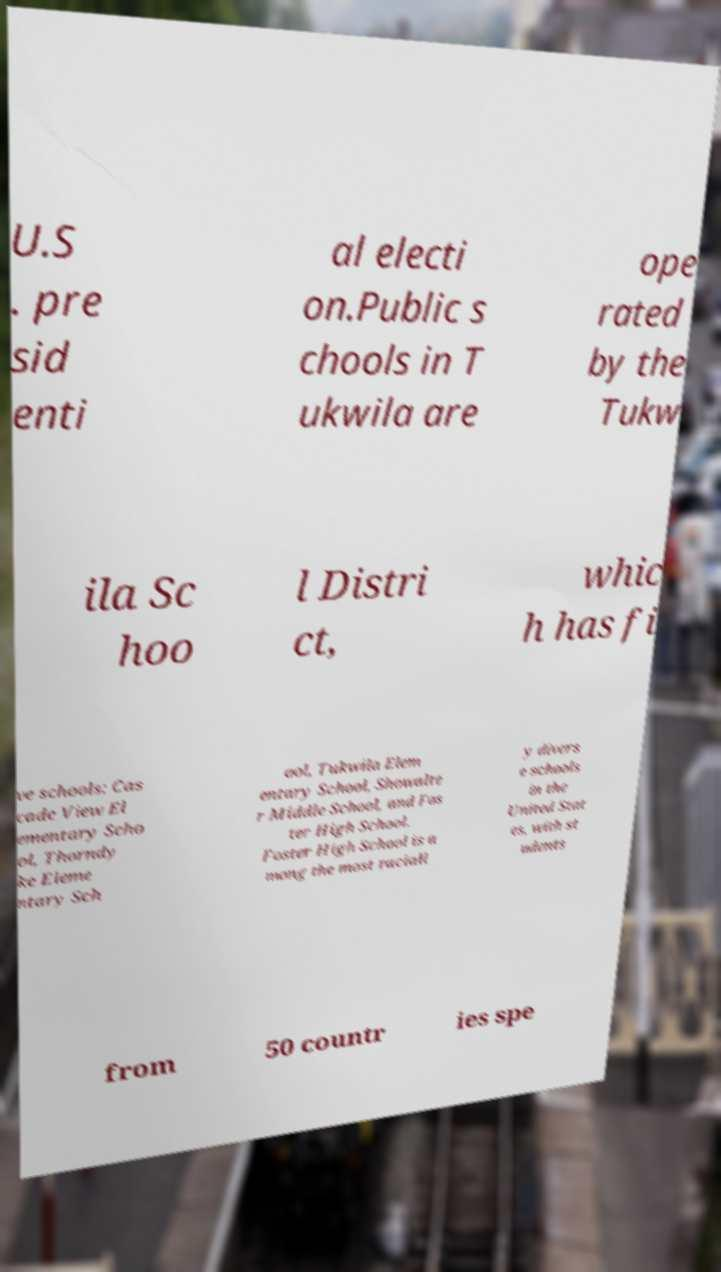I need the written content from this picture converted into text. Can you do that? U.S . pre sid enti al electi on.Public s chools in T ukwila are ope rated by the Tukw ila Sc hoo l Distri ct, whic h has fi ve schools: Cas cade View El ementary Scho ol, Thorndy ke Eleme ntary Sch ool, Tukwila Elem entary School, Showalte r Middle School, and Fos ter High School. Foster High School is a mong the most raciall y divers e schools in the United Stat es, with st udents from 50 countr ies spe 